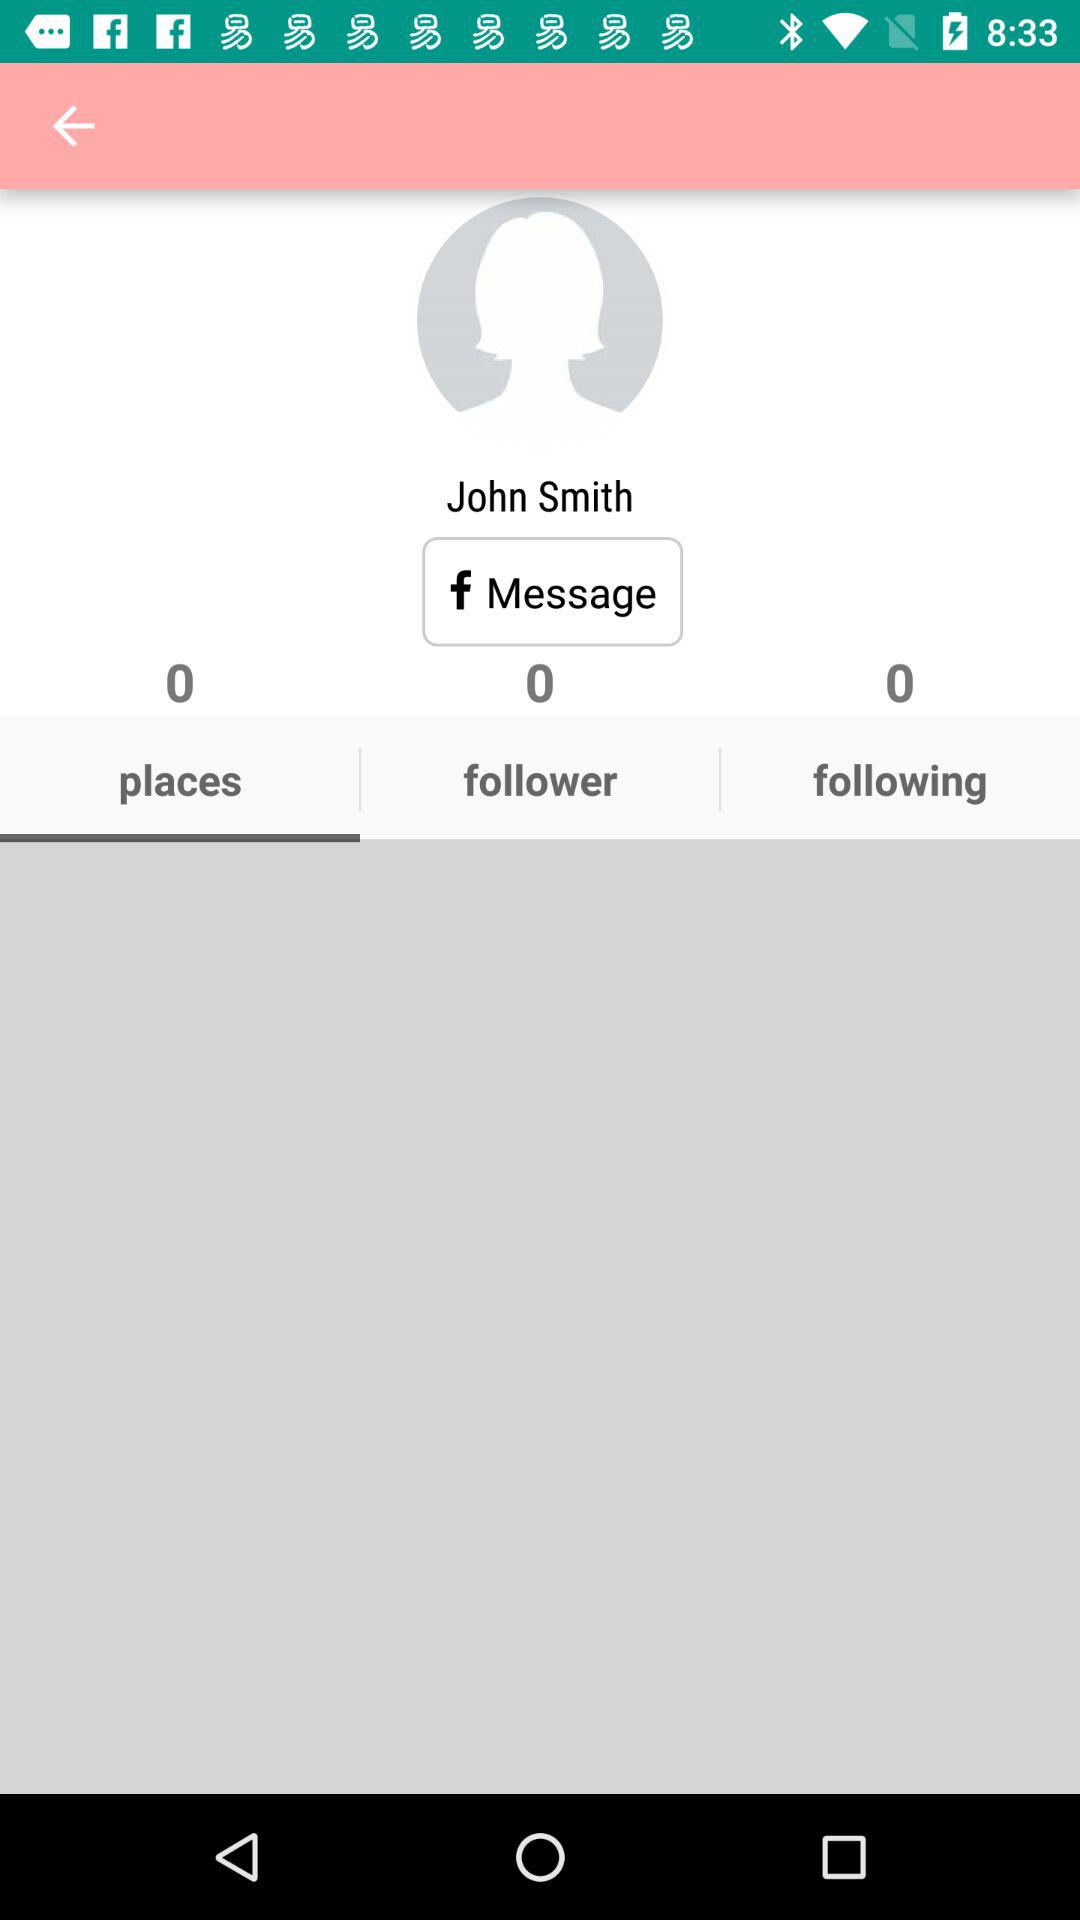What tab am I on? You are on the "places" tab. 